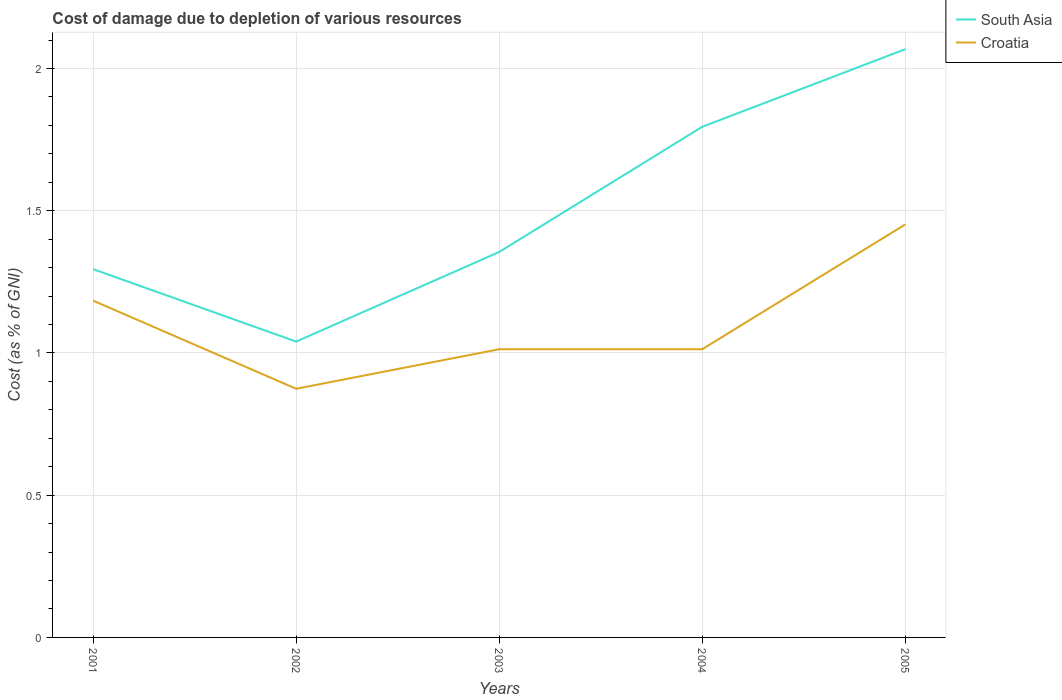How many different coloured lines are there?
Offer a very short reply. 2. Across all years, what is the maximum cost of damage caused due to the depletion of various resources in South Asia?
Your answer should be very brief. 1.04. What is the total cost of damage caused due to the depletion of various resources in Croatia in the graph?
Give a very brief answer. -0.44. What is the difference between the highest and the second highest cost of damage caused due to the depletion of various resources in Croatia?
Ensure brevity in your answer.  0.58. How many lines are there?
Provide a short and direct response. 2. How many years are there in the graph?
Your answer should be very brief. 5. Are the values on the major ticks of Y-axis written in scientific E-notation?
Keep it short and to the point. No. Does the graph contain any zero values?
Offer a terse response. No. Where does the legend appear in the graph?
Offer a very short reply. Top right. How are the legend labels stacked?
Keep it short and to the point. Vertical. What is the title of the graph?
Offer a terse response. Cost of damage due to depletion of various resources. What is the label or title of the X-axis?
Provide a succinct answer. Years. What is the label or title of the Y-axis?
Your answer should be very brief. Cost (as % of GNI). What is the Cost (as % of GNI) in South Asia in 2001?
Your answer should be very brief. 1.29. What is the Cost (as % of GNI) of Croatia in 2001?
Provide a short and direct response. 1.18. What is the Cost (as % of GNI) of South Asia in 2002?
Provide a succinct answer. 1.04. What is the Cost (as % of GNI) in Croatia in 2002?
Make the answer very short. 0.87. What is the Cost (as % of GNI) in South Asia in 2003?
Provide a succinct answer. 1.35. What is the Cost (as % of GNI) of Croatia in 2003?
Offer a very short reply. 1.01. What is the Cost (as % of GNI) of South Asia in 2004?
Your answer should be very brief. 1.8. What is the Cost (as % of GNI) of Croatia in 2004?
Your answer should be compact. 1.01. What is the Cost (as % of GNI) in South Asia in 2005?
Ensure brevity in your answer.  2.07. What is the Cost (as % of GNI) of Croatia in 2005?
Provide a succinct answer. 1.45. Across all years, what is the maximum Cost (as % of GNI) in South Asia?
Provide a succinct answer. 2.07. Across all years, what is the maximum Cost (as % of GNI) in Croatia?
Offer a very short reply. 1.45. Across all years, what is the minimum Cost (as % of GNI) in South Asia?
Your response must be concise. 1.04. Across all years, what is the minimum Cost (as % of GNI) in Croatia?
Keep it short and to the point. 0.87. What is the total Cost (as % of GNI) in South Asia in the graph?
Provide a succinct answer. 7.55. What is the total Cost (as % of GNI) of Croatia in the graph?
Offer a very short reply. 5.54. What is the difference between the Cost (as % of GNI) of South Asia in 2001 and that in 2002?
Your response must be concise. 0.25. What is the difference between the Cost (as % of GNI) of Croatia in 2001 and that in 2002?
Offer a terse response. 0.31. What is the difference between the Cost (as % of GNI) of South Asia in 2001 and that in 2003?
Give a very brief answer. -0.06. What is the difference between the Cost (as % of GNI) in Croatia in 2001 and that in 2003?
Your response must be concise. 0.17. What is the difference between the Cost (as % of GNI) in South Asia in 2001 and that in 2004?
Give a very brief answer. -0.5. What is the difference between the Cost (as % of GNI) of Croatia in 2001 and that in 2004?
Offer a very short reply. 0.17. What is the difference between the Cost (as % of GNI) in South Asia in 2001 and that in 2005?
Offer a very short reply. -0.77. What is the difference between the Cost (as % of GNI) of Croatia in 2001 and that in 2005?
Your answer should be compact. -0.27. What is the difference between the Cost (as % of GNI) in South Asia in 2002 and that in 2003?
Make the answer very short. -0.31. What is the difference between the Cost (as % of GNI) of Croatia in 2002 and that in 2003?
Your answer should be very brief. -0.14. What is the difference between the Cost (as % of GNI) of South Asia in 2002 and that in 2004?
Your answer should be very brief. -0.76. What is the difference between the Cost (as % of GNI) in Croatia in 2002 and that in 2004?
Ensure brevity in your answer.  -0.14. What is the difference between the Cost (as % of GNI) in South Asia in 2002 and that in 2005?
Give a very brief answer. -1.03. What is the difference between the Cost (as % of GNI) in Croatia in 2002 and that in 2005?
Your answer should be very brief. -0.58. What is the difference between the Cost (as % of GNI) of South Asia in 2003 and that in 2004?
Provide a short and direct response. -0.44. What is the difference between the Cost (as % of GNI) in South Asia in 2003 and that in 2005?
Provide a succinct answer. -0.71. What is the difference between the Cost (as % of GNI) of Croatia in 2003 and that in 2005?
Offer a terse response. -0.44. What is the difference between the Cost (as % of GNI) of South Asia in 2004 and that in 2005?
Provide a succinct answer. -0.27. What is the difference between the Cost (as % of GNI) of Croatia in 2004 and that in 2005?
Your answer should be very brief. -0.44. What is the difference between the Cost (as % of GNI) of South Asia in 2001 and the Cost (as % of GNI) of Croatia in 2002?
Your answer should be compact. 0.42. What is the difference between the Cost (as % of GNI) in South Asia in 2001 and the Cost (as % of GNI) in Croatia in 2003?
Your answer should be very brief. 0.28. What is the difference between the Cost (as % of GNI) of South Asia in 2001 and the Cost (as % of GNI) of Croatia in 2004?
Make the answer very short. 0.28. What is the difference between the Cost (as % of GNI) in South Asia in 2001 and the Cost (as % of GNI) in Croatia in 2005?
Offer a terse response. -0.16. What is the difference between the Cost (as % of GNI) in South Asia in 2002 and the Cost (as % of GNI) in Croatia in 2003?
Provide a succinct answer. 0.03. What is the difference between the Cost (as % of GNI) in South Asia in 2002 and the Cost (as % of GNI) in Croatia in 2004?
Offer a terse response. 0.03. What is the difference between the Cost (as % of GNI) in South Asia in 2002 and the Cost (as % of GNI) in Croatia in 2005?
Offer a very short reply. -0.41. What is the difference between the Cost (as % of GNI) of South Asia in 2003 and the Cost (as % of GNI) of Croatia in 2004?
Your response must be concise. 0.34. What is the difference between the Cost (as % of GNI) of South Asia in 2003 and the Cost (as % of GNI) of Croatia in 2005?
Provide a short and direct response. -0.1. What is the difference between the Cost (as % of GNI) of South Asia in 2004 and the Cost (as % of GNI) of Croatia in 2005?
Provide a succinct answer. 0.34. What is the average Cost (as % of GNI) in South Asia per year?
Make the answer very short. 1.51. What is the average Cost (as % of GNI) in Croatia per year?
Provide a short and direct response. 1.11. In the year 2001, what is the difference between the Cost (as % of GNI) of South Asia and Cost (as % of GNI) of Croatia?
Offer a very short reply. 0.11. In the year 2002, what is the difference between the Cost (as % of GNI) of South Asia and Cost (as % of GNI) of Croatia?
Provide a short and direct response. 0.17. In the year 2003, what is the difference between the Cost (as % of GNI) in South Asia and Cost (as % of GNI) in Croatia?
Your answer should be compact. 0.34. In the year 2004, what is the difference between the Cost (as % of GNI) in South Asia and Cost (as % of GNI) in Croatia?
Ensure brevity in your answer.  0.78. In the year 2005, what is the difference between the Cost (as % of GNI) in South Asia and Cost (as % of GNI) in Croatia?
Offer a very short reply. 0.62. What is the ratio of the Cost (as % of GNI) of South Asia in 2001 to that in 2002?
Keep it short and to the point. 1.24. What is the ratio of the Cost (as % of GNI) of Croatia in 2001 to that in 2002?
Your answer should be very brief. 1.35. What is the ratio of the Cost (as % of GNI) in South Asia in 2001 to that in 2003?
Ensure brevity in your answer.  0.96. What is the ratio of the Cost (as % of GNI) of Croatia in 2001 to that in 2003?
Offer a very short reply. 1.17. What is the ratio of the Cost (as % of GNI) in South Asia in 2001 to that in 2004?
Ensure brevity in your answer.  0.72. What is the ratio of the Cost (as % of GNI) of Croatia in 2001 to that in 2004?
Your answer should be compact. 1.17. What is the ratio of the Cost (as % of GNI) of South Asia in 2001 to that in 2005?
Provide a succinct answer. 0.63. What is the ratio of the Cost (as % of GNI) of Croatia in 2001 to that in 2005?
Offer a terse response. 0.82. What is the ratio of the Cost (as % of GNI) of South Asia in 2002 to that in 2003?
Provide a short and direct response. 0.77. What is the ratio of the Cost (as % of GNI) of Croatia in 2002 to that in 2003?
Your response must be concise. 0.86. What is the ratio of the Cost (as % of GNI) of South Asia in 2002 to that in 2004?
Give a very brief answer. 0.58. What is the ratio of the Cost (as % of GNI) of Croatia in 2002 to that in 2004?
Make the answer very short. 0.86. What is the ratio of the Cost (as % of GNI) of South Asia in 2002 to that in 2005?
Keep it short and to the point. 0.5. What is the ratio of the Cost (as % of GNI) of Croatia in 2002 to that in 2005?
Make the answer very short. 0.6. What is the ratio of the Cost (as % of GNI) of South Asia in 2003 to that in 2004?
Keep it short and to the point. 0.75. What is the ratio of the Cost (as % of GNI) of South Asia in 2003 to that in 2005?
Your answer should be very brief. 0.66. What is the ratio of the Cost (as % of GNI) of Croatia in 2003 to that in 2005?
Keep it short and to the point. 0.7. What is the ratio of the Cost (as % of GNI) of South Asia in 2004 to that in 2005?
Offer a very short reply. 0.87. What is the ratio of the Cost (as % of GNI) in Croatia in 2004 to that in 2005?
Ensure brevity in your answer.  0.7. What is the difference between the highest and the second highest Cost (as % of GNI) in South Asia?
Keep it short and to the point. 0.27. What is the difference between the highest and the second highest Cost (as % of GNI) in Croatia?
Your answer should be compact. 0.27. What is the difference between the highest and the lowest Cost (as % of GNI) of South Asia?
Provide a succinct answer. 1.03. What is the difference between the highest and the lowest Cost (as % of GNI) in Croatia?
Provide a succinct answer. 0.58. 